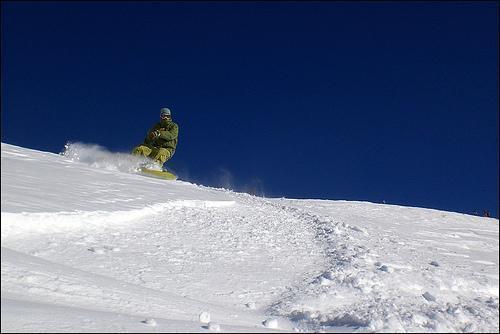How many snowboarders are in this picture?
Give a very brief answer. 1. 